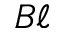<formula> <loc_0><loc_0><loc_500><loc_500>B \ell</formula> 